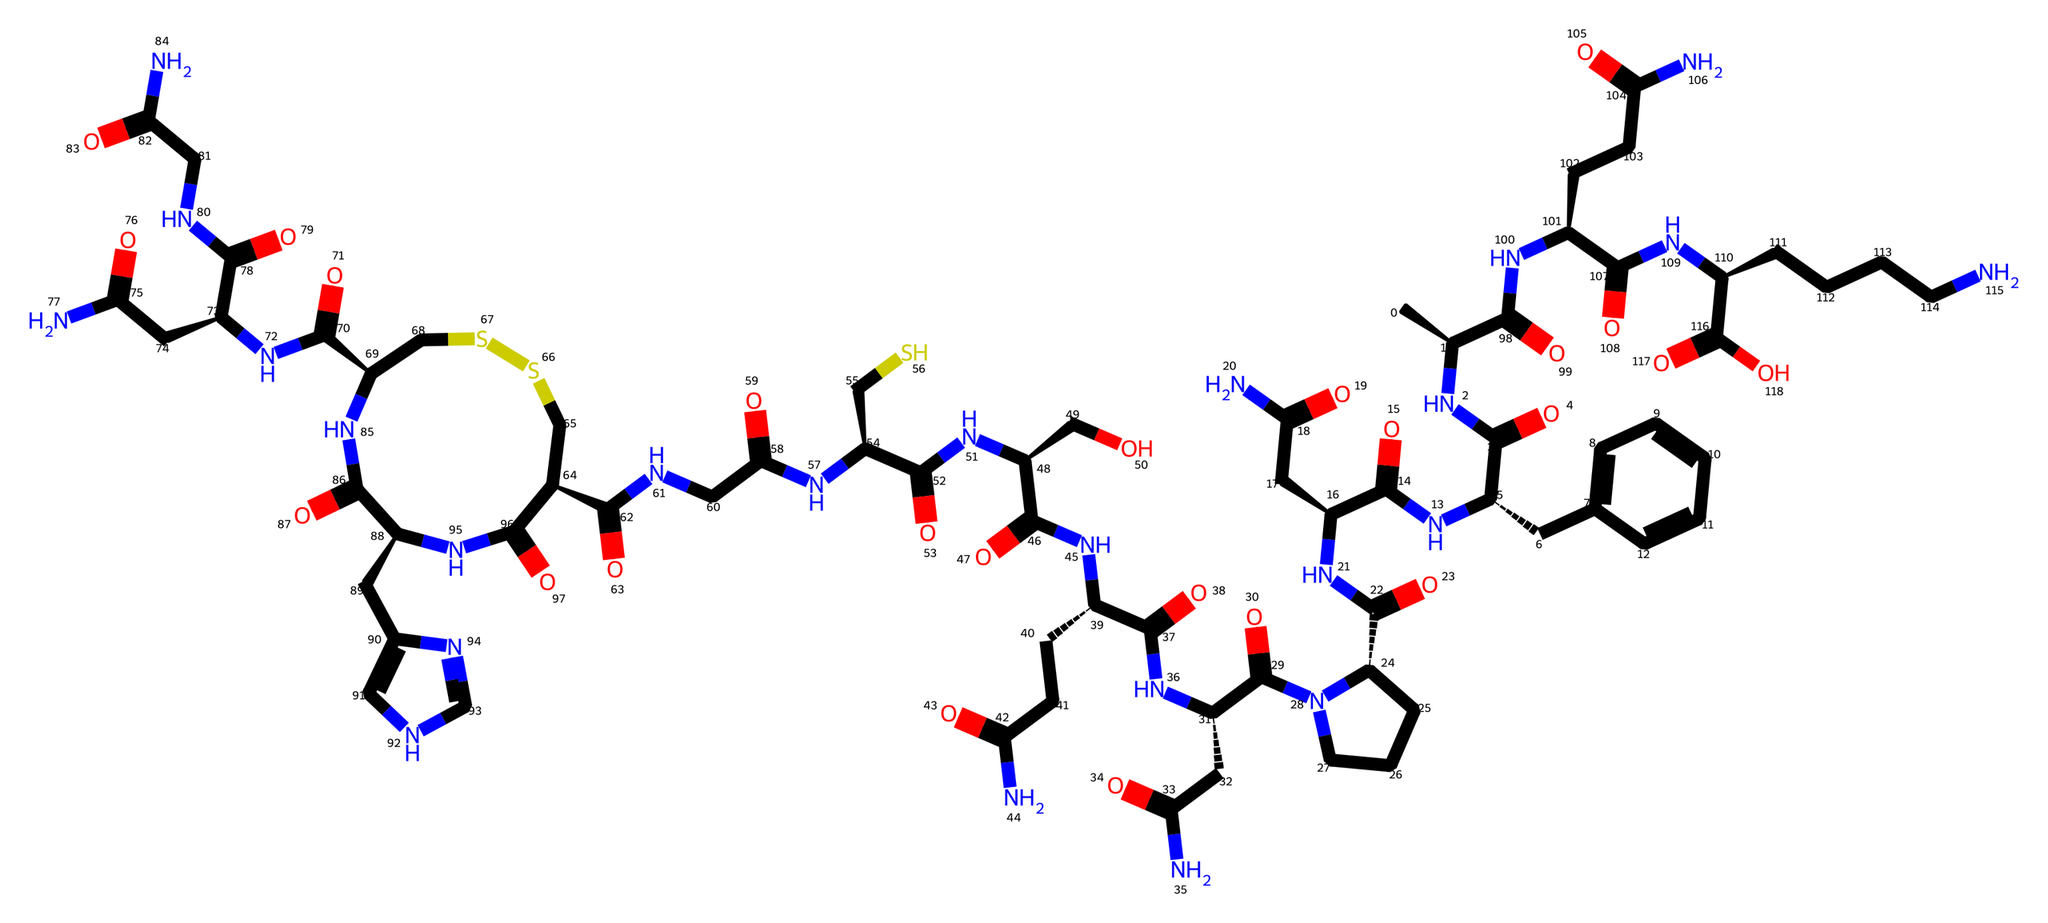How many carbon atoms are in the structure? By examining the SMILES representation, we can count the number of carbon atoms represented by the letter 'C'. Each 'C' corresponds to a carbon atom. In total, there are over 40 carbon atoms in the provided structure.
Answer: over 40 What is the main functional group present in oxytocin? In the structure, we can identify multiple amide groups (C(=O)N) which are characterized by a carbonyl attached to a nitrogen atom. The presence of these groups is a key feature of oxytocin's structure.
Answer: amide How many rings are present in the molecule? By analyzing the SMILES notation, we identify that there is one cyclic structure indicated by the notation 'C1=CC=CC=C1', which represents a six-membered carbon ring. Other parts of the molecule are linear. Thus, there is one ring present.
Answer: one What type of bonding is primarily involved in the oxytocin structure? The presence of the nitrogen atoms connected to carbonyl groups indicates that there are several peptide bonds in the molecule, as seen in protein structures. Therefore, the predominant type of bonding is through peptide linkages connecting amino acids.
Answer: peptide What charge does the overall molecule have? Analyzing the structure, we see that most of the functional groups do not carry a charge, but since there are amine groups (–NH) and a carboxylic acid (–COOH), the molecule is neutral overall in a physiological pH environment.
Answer: neutral 